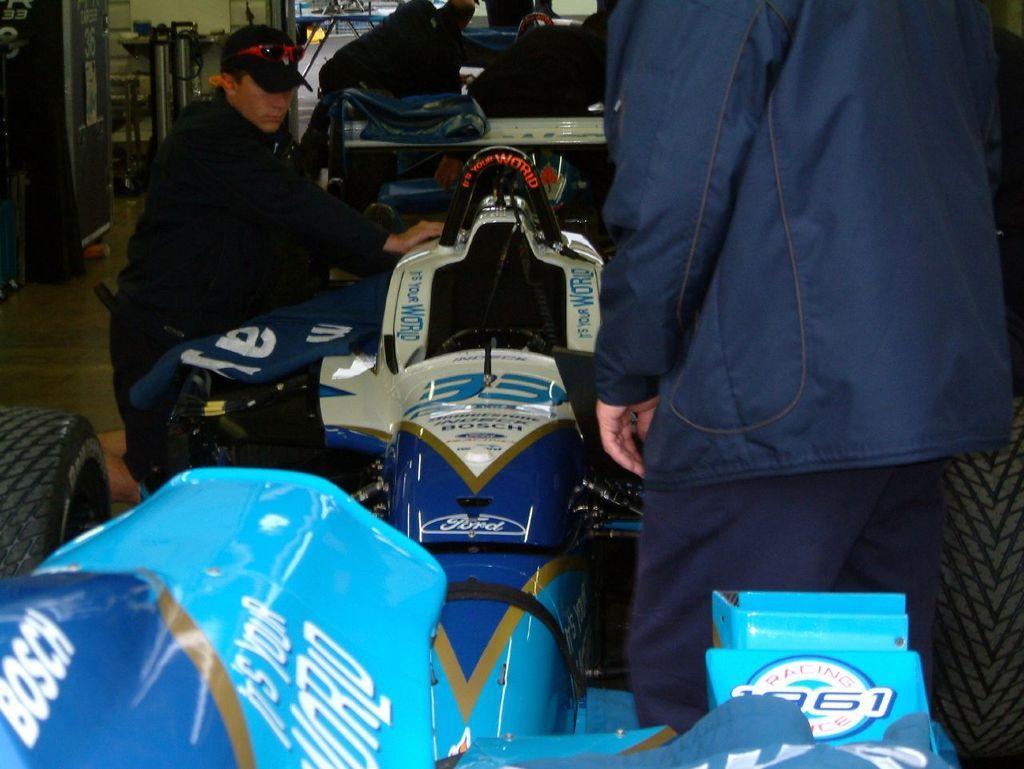Describe this image in one or two sentences. In this picture I can see the vehicle on the surface. I can see the people. 